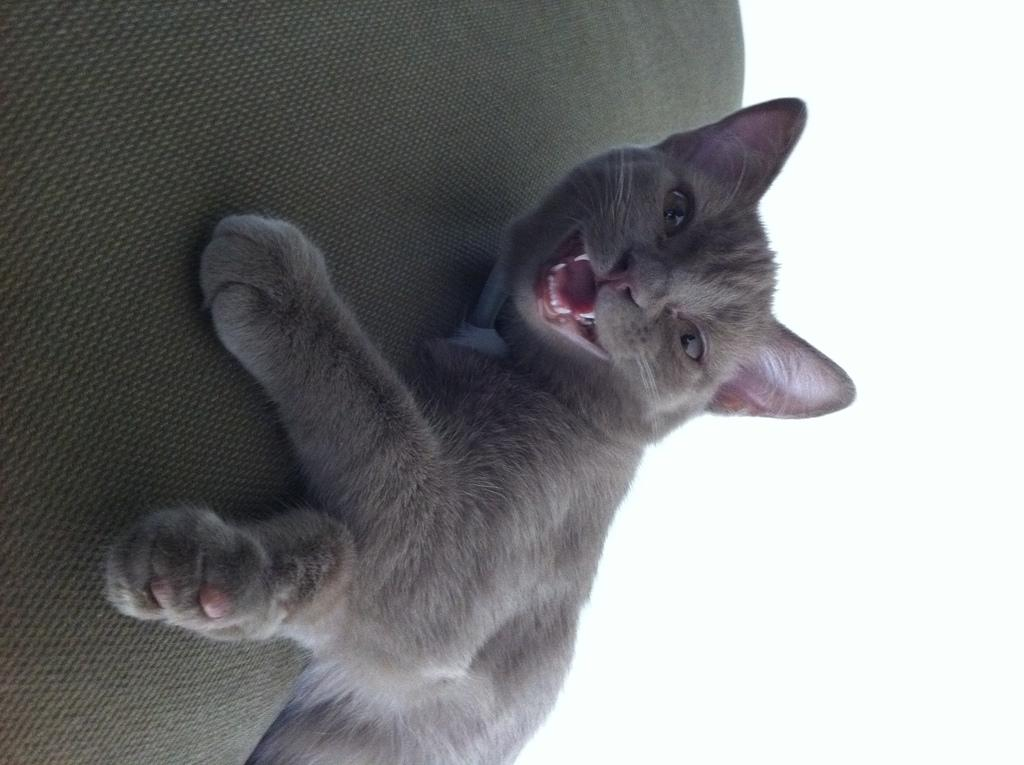What type of animal is in the image? There is a cat in the image. Where is the cat located? The cat is on a couch. What color is the right side of the image? The right side of the image is white in color. What type of offer is the cat making to the viewer in the image? The image does not depict the cat making any offer to the viewer. 